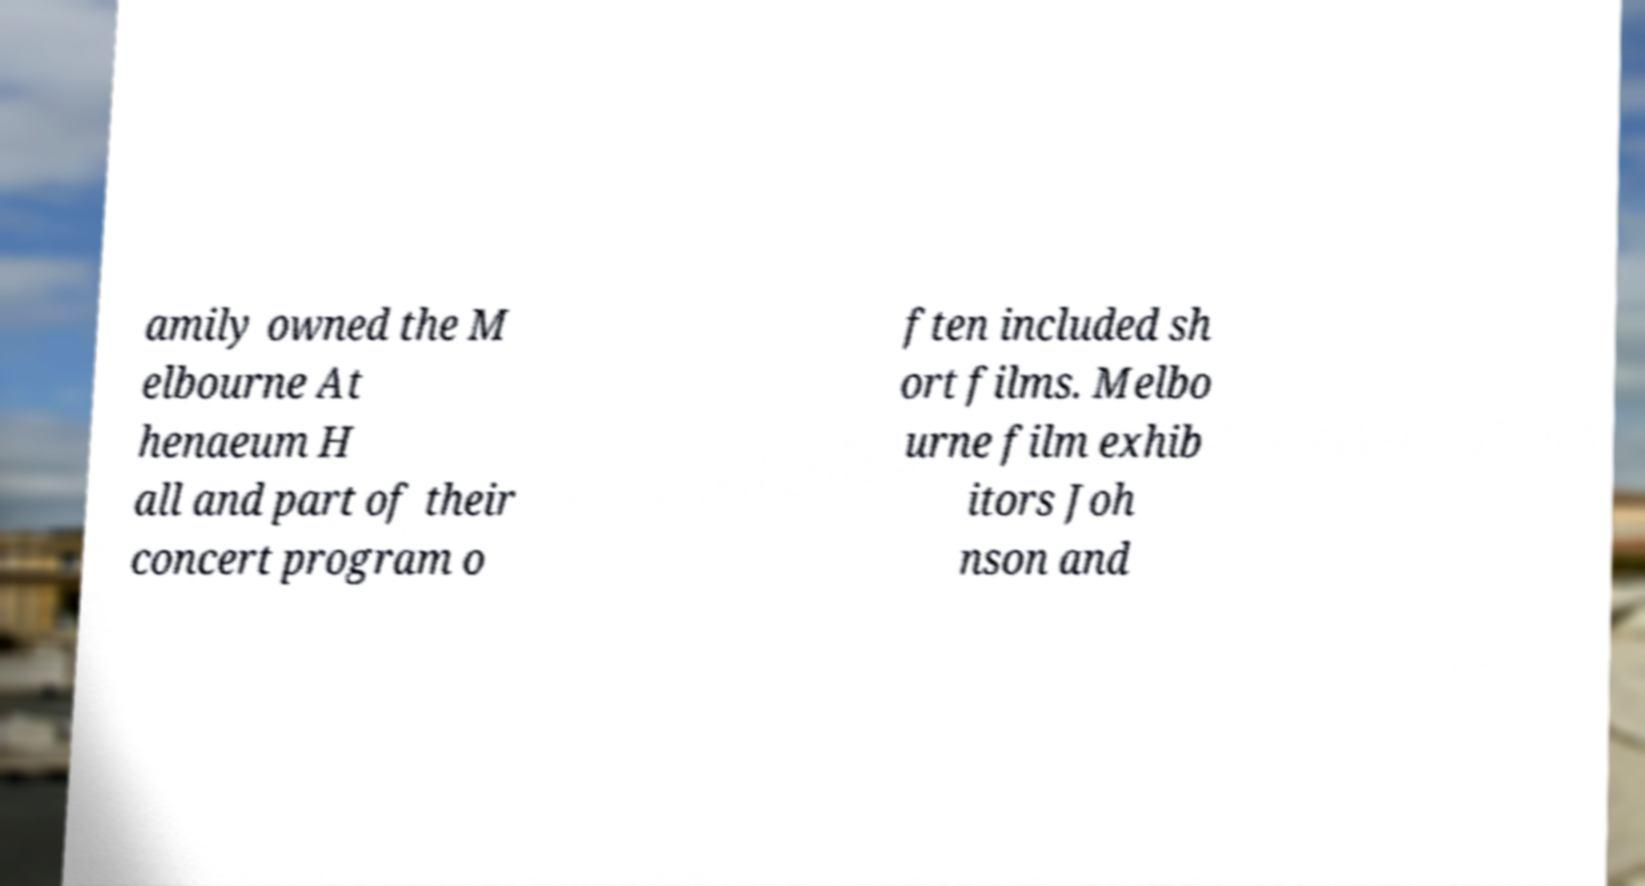Can you accurately transcribe the text from the provided image for me? amily owned the M elbourne At henaeum H all and part of their concert program o ften included sh ort films. Melbo urne film exhib itors Joh nson and 